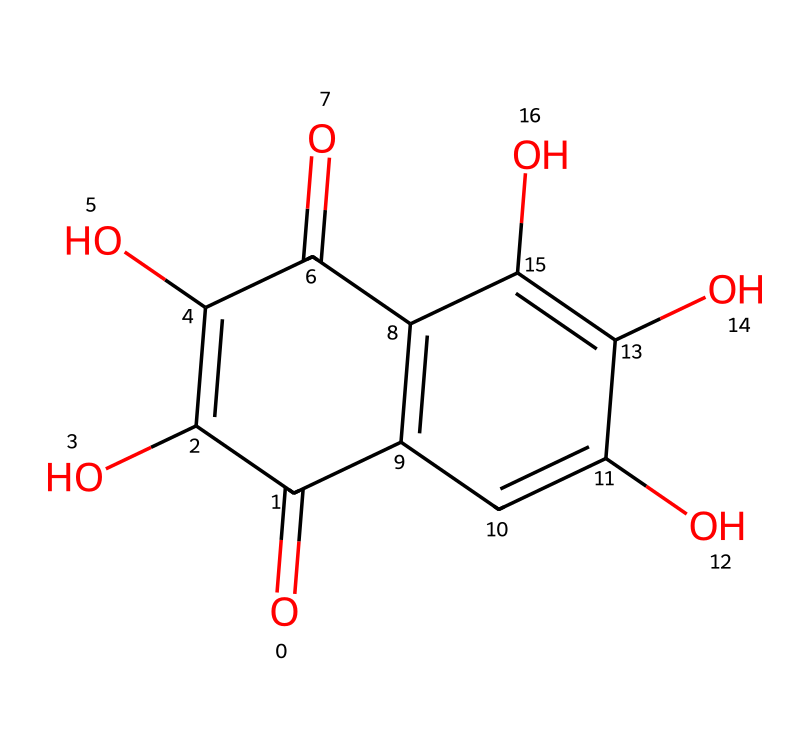How many hydroxyl (–OH) groups are present in quercetin? By examining the structure, we can identify the presence of multiple –OH groups. Counting the distinct –OH groups in the diagram reveals that there are five such groups attached to the aromatic rings.
Answer: five What is the total number of carbon atoms in the quercetin structure? To find the number of carbon atoms, we should count each carbon represented in the structure. After careful counting of the carbon atoms in the entire structure, it can be determined that there are 15 carbon atoms present in quercetin.
Answer: fifteen Is quercetin classified as a flavonoid? Quercetin has a specific structure that includes two benzene rings and a ketone group, which fits the definition of flavonoids. Therefore, we classify quercetin in this category.
Answer: yes What is the molecular formula of quercetin? By considering the elements presented in the structure, we count carbon, hydrogen, and oxygen atoms and compile them into the molecular formula. This leads us to identify that the molecular formula for quercetin is C15H10O7.
Answer: C15H10O7 Which part of quercetin is responsible for its antioxidant properties? The structure of quercetin contains several hydroxyl groups (–OH). These groups are primarily responsible for its antioxidant activity, as they can donate electrons to neutralize free radicals.
Answer: hydroxyl groups How many double bonds are present in the quercetin structure? In the quercetin structure, we can identify the carbon-carbon double bonds and any carbon-oxygen double bonds. By examining the structure carefully, we find that there are five carbon-carbon double bonds in quercetin.
Answer: five What functional groups are present in quercetin besides hydroxyl groups? Looking closely at the structure, besides the hydroxyl groups, we also see that there are carbonyl (–C=O) groups present. This analysis allows us to identify those functional groups in quercetin.
Answer: carbonyl groups 